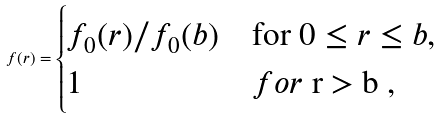<formula> <loc_0><loc_0><loc_500><loc_500>f ( r ) = \begin{cases} f _ { 0 } ( r ) / f _ { 0 } ( b ) & \text {for $0\leq r\leq b$} , \\ 1 & f o r $ r > b $ , \end{cases}</formula> 